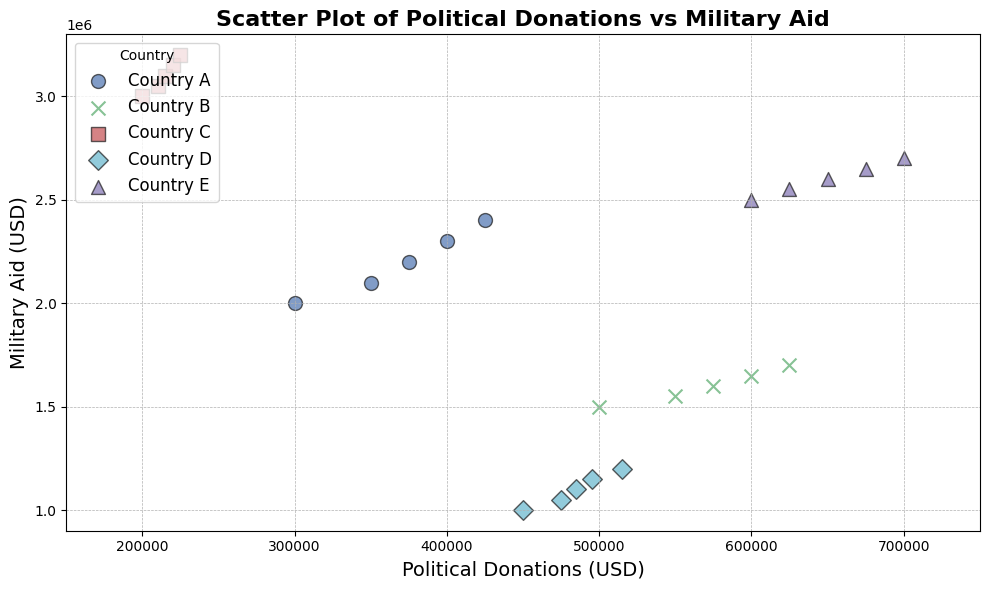Which country received the highest amount of military aid? By observing the scatter plot, you can identify that Country C has the highest value on the y-axis (military aid), surpassing the other countries.
Answer: Country C Is there a clear relationship between political donations and military aid for any country? By looking at the scatter points for each country, it's evident that there is a positive correlation between political donations and military aid for all countries, as higher political donations correspond to higher military aid.
Answer: Yes Which country has the highest political donations and how much is it? On the x-axis (political donations), Country E's scatter points are the furthest right compared to other countries. The highest value (2019) is $700,000.
Answer: Country E, $700,000 Between which two countries does the difference in military aid appear the largest? Visually comparing the distance between the scatter points along the y-axis, the largest difference is observed between Country B and Country C. In particular, Country C in 2019 has around $3,200,000 military aid, while Country B in 2019 has around $1,700,000. The difference is $1,500,000.
Answer: Country B and Country C Do any countries receive more military aid despite having lower political donations compared to others? Country C consistently receives more military aid compared to others; however, its political donations are lower compared to Country E, suggesting an imbalance where lower donations still result in higher aid.
Answer: Yes What is the average military aid received by Country D over the years? The military aid values for Country D across 2015 to 2019 are $1,000,000, $1,050,000, $1,100,000, $1,150,000, and $1,200,000. Adding these yields $5,500,000, and dividing by 5 gives $1,100,000 as the average military aid.
Answer: $1,100,000 How does the military aid trend of Country A progress over the years? Inspecting the vertical progression of Country A's scatter points from 2015 to 2019 shows a steady increase in military aid from $2,000,000 to $2,400,000.
Answer: Steadily increasing Which country has the largest increase in political donations from 2015 to 2019? By observing the scatter points on the x-axis for each country, Country E shows the largest increase in political donations from $600,000 in 2015 to $700,000 in 2019, which is a $100,000 increase.
Answer: Country E 